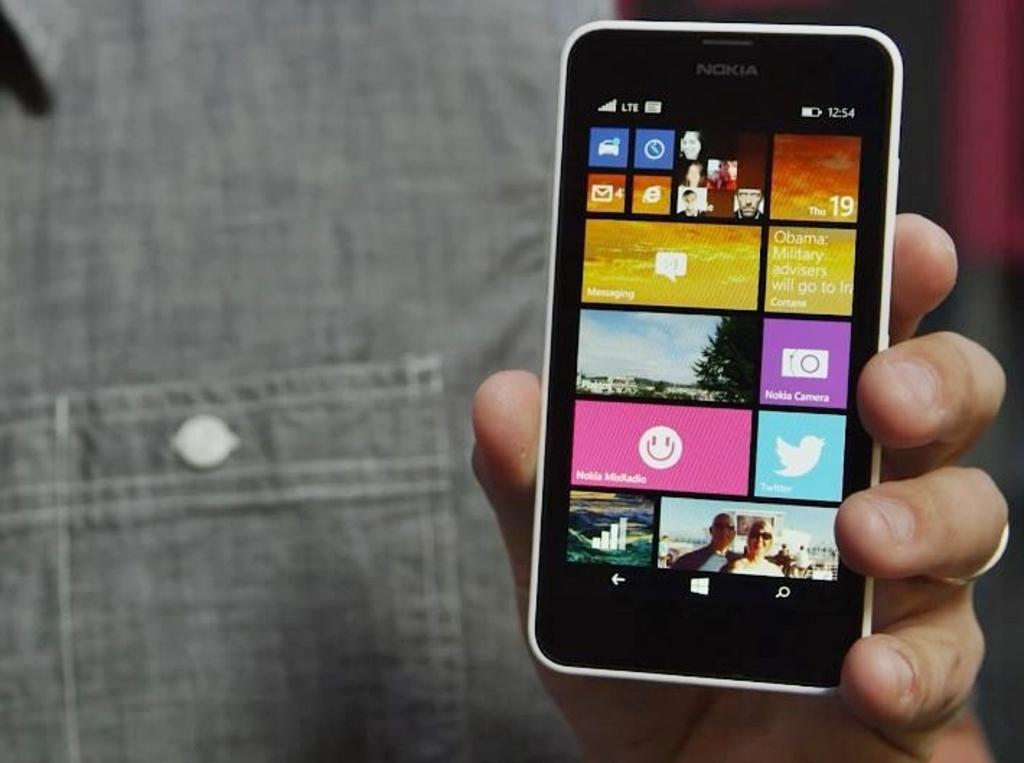Could you give a brief overview of what you see in this image? In this picture we can see a person holding a mobile phone, we can see a screen here. 